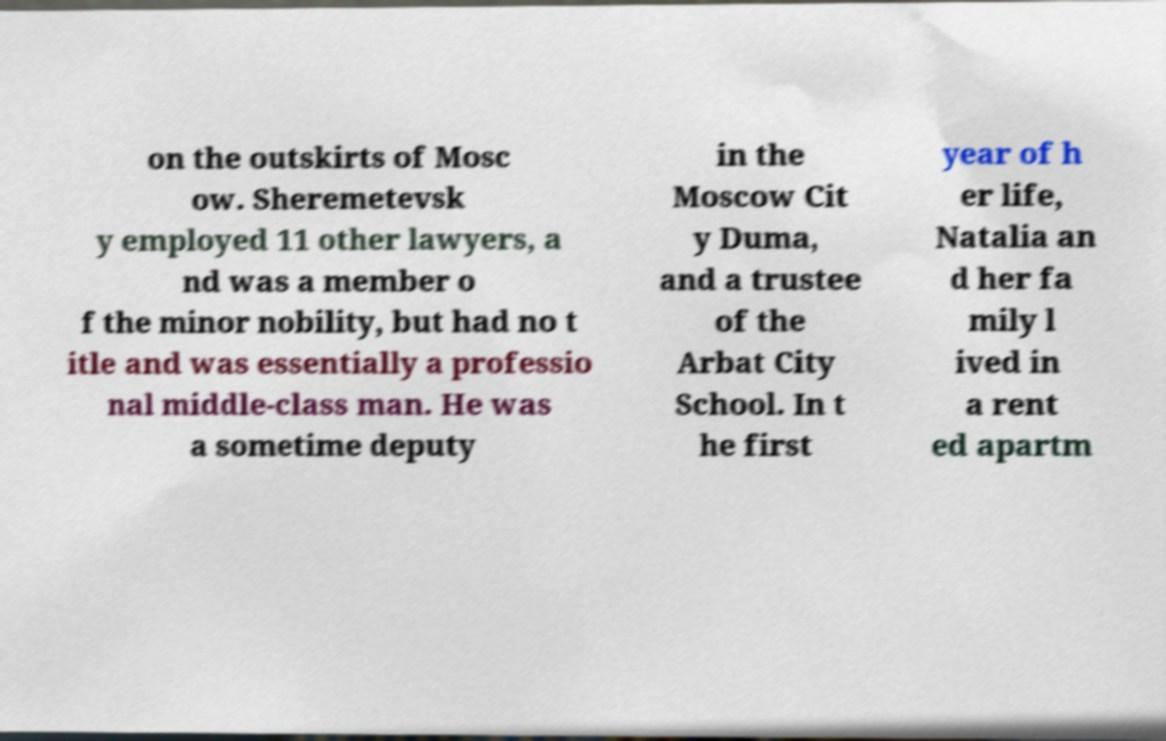Could you assist in decoding the text presented in this image and type it out clearly? on the outskirts of Mosc ow. Sheremetevsk y employed 11 other lawyers, a nd was a member o f the minor nobility, but had no t itle and was essentially a professio nal middle-class man. He was a sometime deputy in the Moscow Cit y Duma, and a trustee of the Arbat City School. In t he first year of h er life, Natalia an d her fa mily l ived in a rent ed apartm 